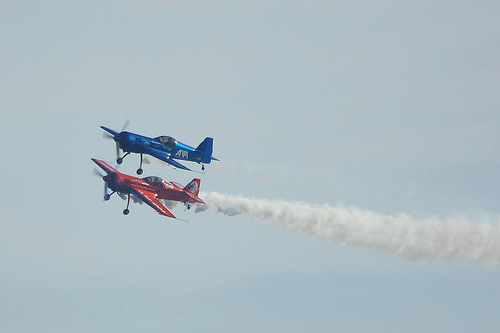Are these kinds of events safe for the pilots? While aerobatic flying is inherently riskier than commercial flight, pilots are highly trained professionals. Safety measures are rigorously followed during such events, including the use of specialized aircraft, pre-flight checks, and adherence to strict safety protocols. 